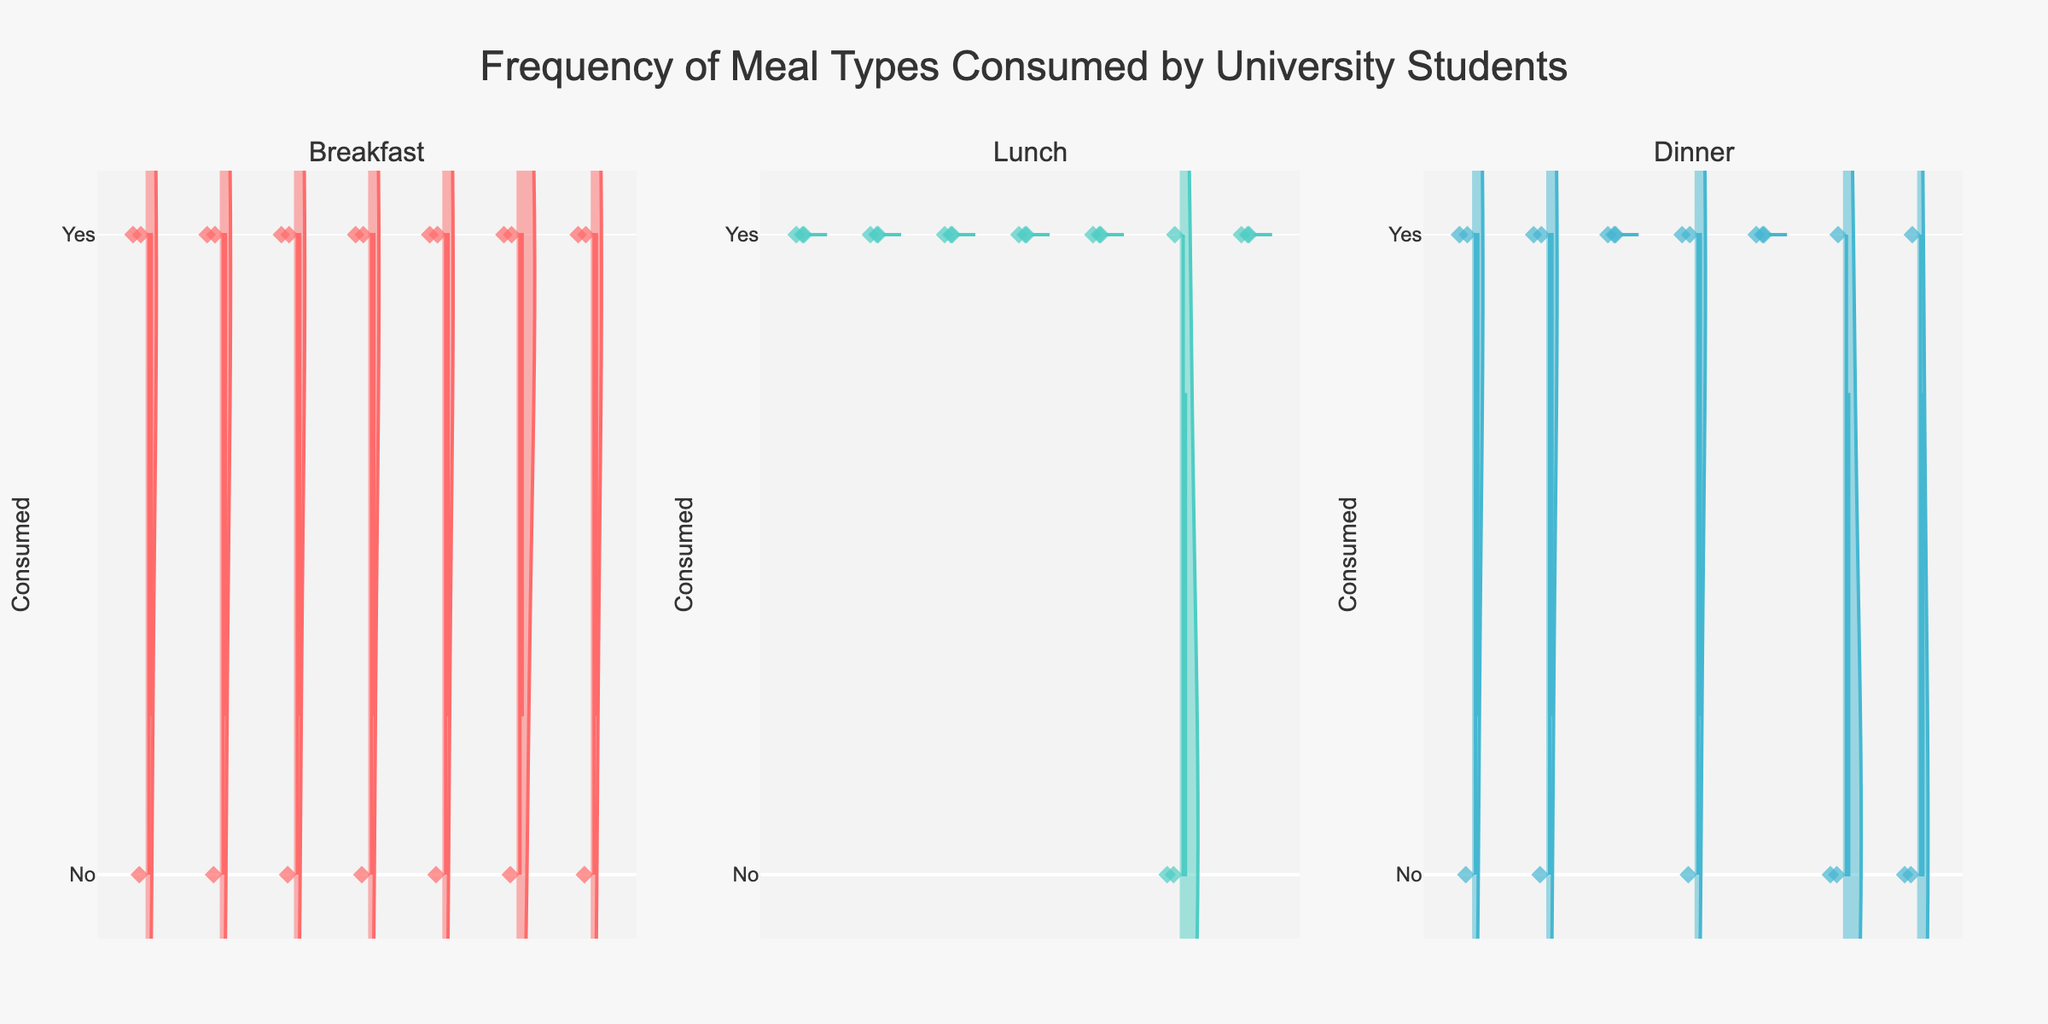What is the title of the figure? The title of the figure is usually found at the top of the chart and is often larger or bolder than other text. It provides a summary of the data presented.
Answer: Frequency of Meal Types Consumed by University Students Which meal type had the highest frequency on Wednesday? To answer this, look at each violin plot corresponding to Wednesday for Breakfast, Lunch, and Dinner subplots. The highest frequency will be the one where the data points are closer to the 'Yes' mark.
Answer: Dinner What is the range of the y-axis? The range of the y-axis can be identified by looking at the axis labels from the minimum to maximum value.
Answer: -0.1 to 1.1 On which day did students skip breakfast the most? To find this, observe the violin plot for Breakfast across all days. The day with values skewed the most towards 'No' will signify skipping breakfast the most.
Answer: Tuesday Which days show the most inconsistency in lunch frequency? The violin plots' shapes indicate variability. Look for days with wider plots, which show high variability around 'Yes' and 'No'.
Answer: Saturday How does the frequency of dinner consumption vary from Monday to Thursday? Examine the violin plots for Dinner from Monday to Thursday and observe the changes in spread and central distribution of data points.
Answer: It varies: Monday has mixed frequencies, Tuesday and Thursday show some zeroes, while Wednesday is consistent What pattern can you observe in breakfast consumption during weekdays vs. weekends? Compare the violin plots for Breakfast between Monday to Friday and Saturday to Sunday. Note the differences in spread and central tendency.
Answer: Weekdays show varied but higher overall consumption; weekends show more skipping Is there a day where all students had lunch? Determine if there is any day where violin plots for Lunch have all data points at 'Yes' without any points at 'No'.
Answer: Yes, Wednesday How often did students have dinner on weekends compared to weekdays? Look for the violin plots for Dinner during weekdays (Monday to Friday) and compare them to those on Saturday and Sunday.
Answer: More consistent on weekdays; more variability and skipping on weekends Which meal type shows the most consistent consumption rates throughout the week? Analyze the violin plots across all days for each meal type and identify which has the least variability or most points close to 'Yes'.
Answer: Lunch 